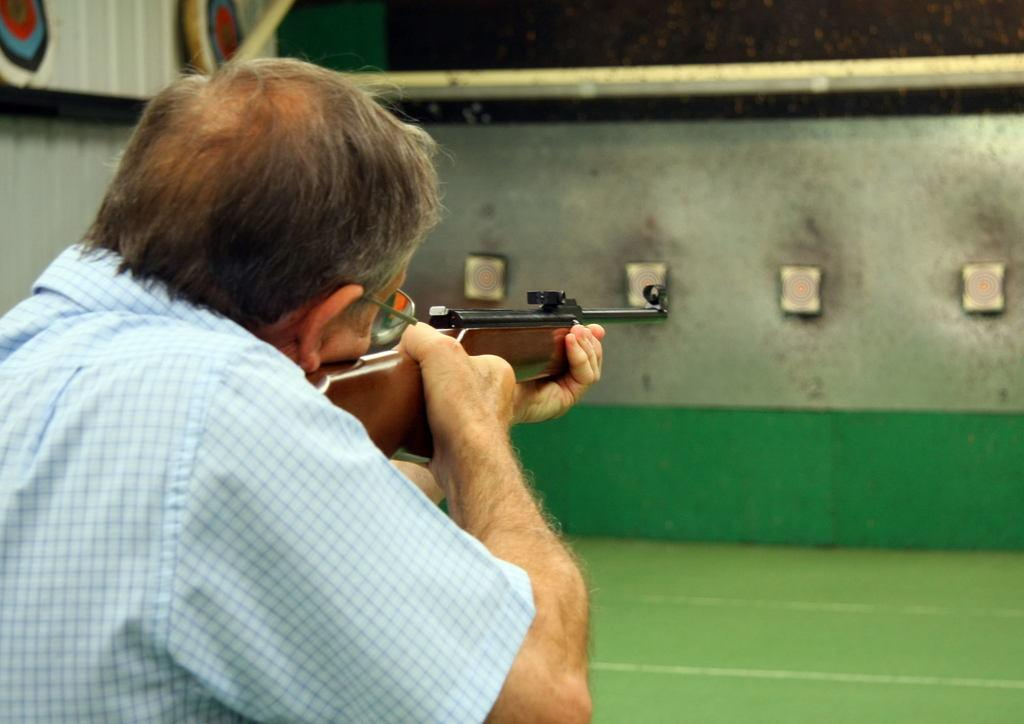What is the person on the left side of the image holding? The person is holding a gun in the image. What is located in the middle of the image? There is a wall in the middle of the image. What can be seen in the top left corner of the image? There is a fence visible in the top left corner of the image. What is visible at the top of the image? There is a pipe visible at the top of the image. What type of test can be seen being conducted in the image? There is no test being conducted in the image; it features a person holding a gun and other elements like a wall, fence, and pipe. 